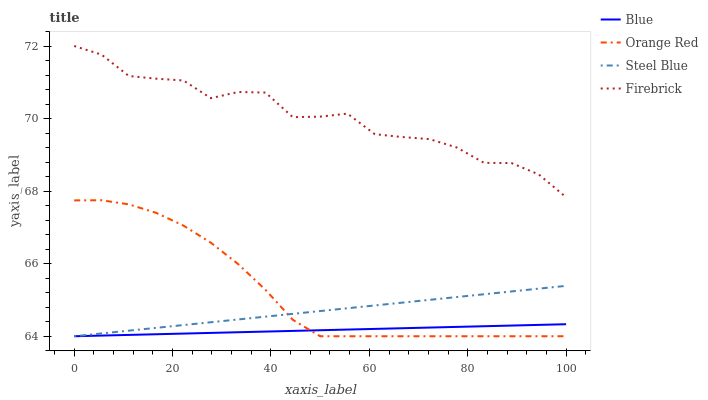Does Blue have the minimum area under the curve?
Answer yes or no. Yes. Does Firebrick have the maximum area under the curve?
Answer yes or no. Yes. Does Orange Red have the minimum area under the curve?
Answer yes or no. No. Does Orange Red have the maximum area under the curve?
Answer yes or no. No. Is Blue the smoothest?
Answer yes or no. Yes. Is Firebrick the roughest?
Answer yes or no. Yes. Is Orange Red the smoothest?
Answer yes or no. No. Is Orange Red the roughest?
Answer yes or no. No. Does Blue have the lowest value?
Answer yes or no. Yes. Does Firebrick have the lowest value?
Answer yes or no. No. Does Firebrick have the highest value?
Answer yes or no. Yes. Does Orange Red have the highest value?
Answer yes or no. No. Is Orange Red less than Firebrick?
Answer yes or no. Yes. Is Firebrick greater than Orange Red?
Answer yes or no. Yes. Does Blue intersect Orange Red?
Answer yes or no. Yes. Is Blue less than Orange Red?
Answer yes or no. No. Is Blue greater than Orange Red?
Answer yes or no. No. Does Orange Red intersect Firebrick?
Answer yes or no. No. 